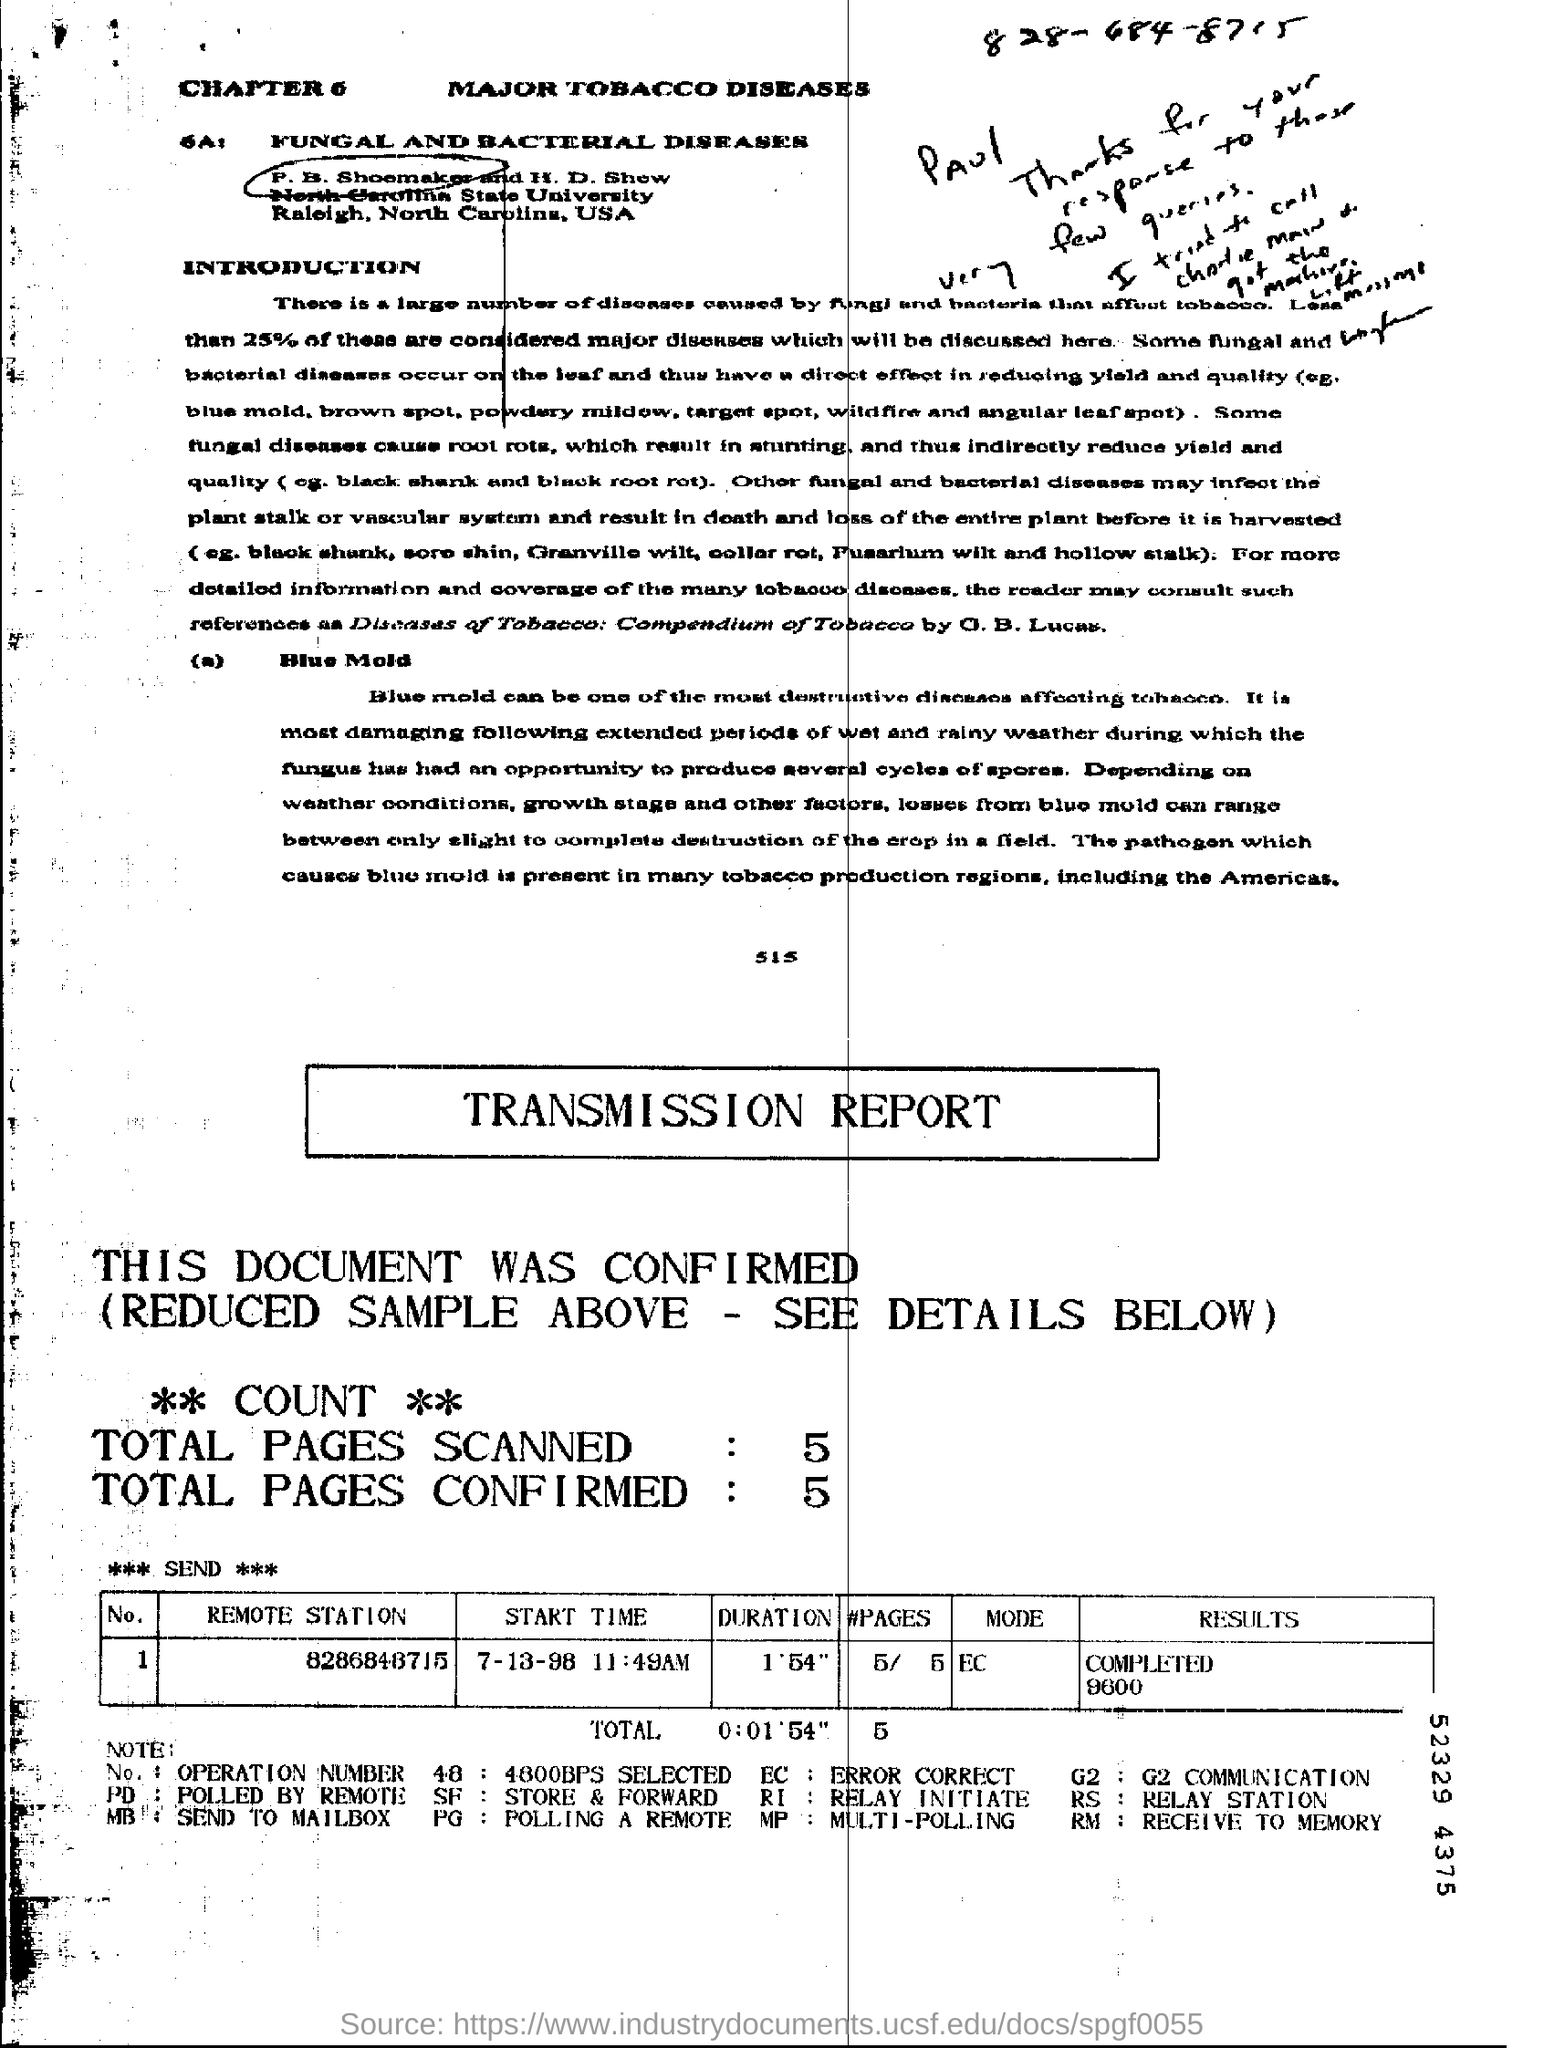Identify some key points in this picture. SF stands for store and forward, which is a method of transmitting data in which information is stored temporarily and then forwarded to its intended recipient. The remote station number is 8286848715. In total, 5 pages were scanned. The name of the chapter is "Major Tobacco-Related Diseases. 